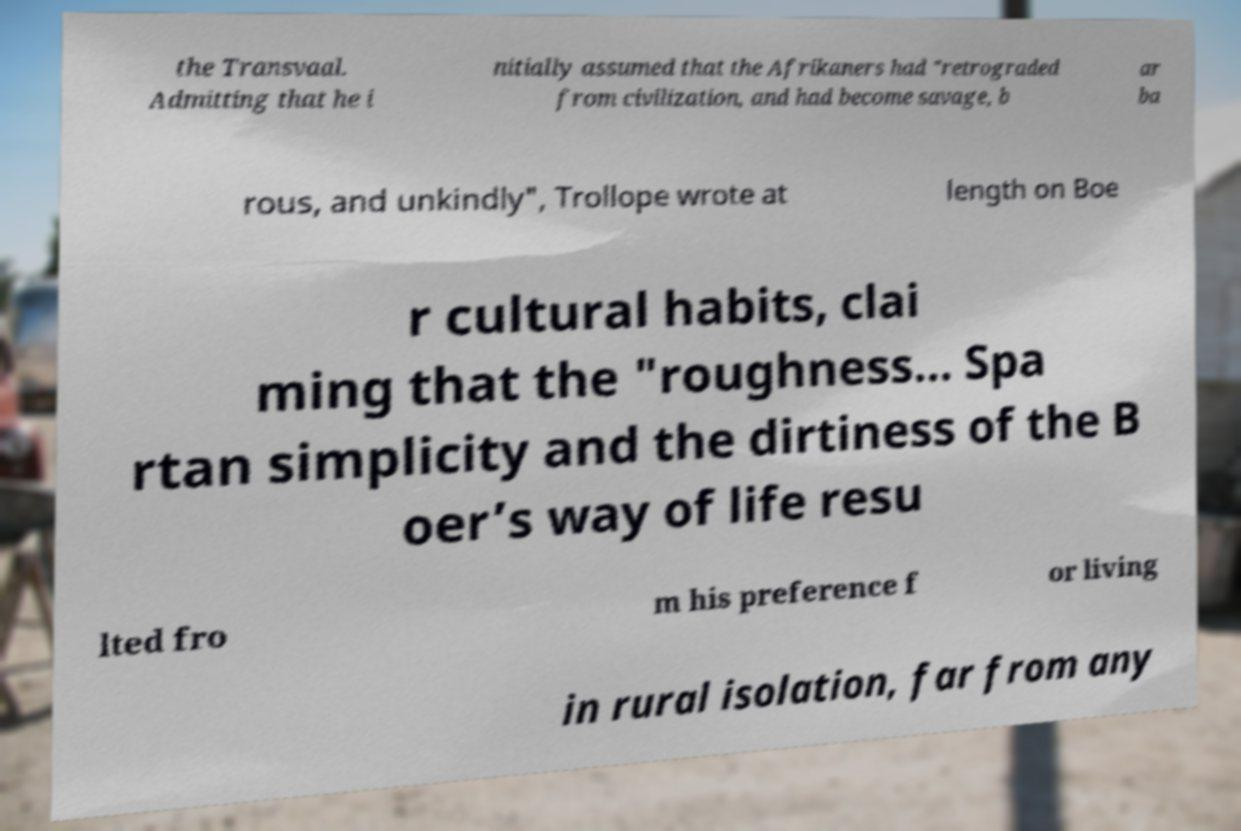Could you extract and type out the text from this image? the Transvaal. Admitting that he i nitially assumed that the Afrikaners had "retrograded from civilization, and had become savage, b ar ba rous, and unkindly", Trollope wrote at length on Boe r cultural habits, clai ming that the "roughness... Spa rtan simplicity and the dirtiness of the B oer’s way of life resu lted fro m his preference f or living in rural isolation, far from any 